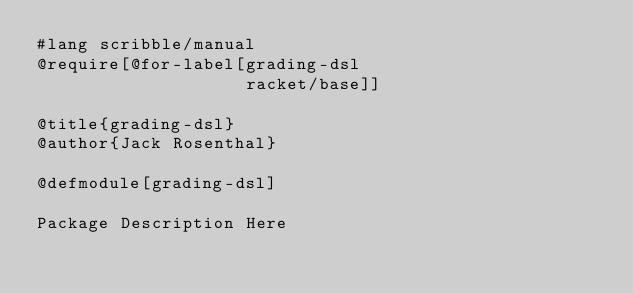<code> <loc_0><loc_0><loc_500><loc_500><_Racket_>#lang scribble/manual
@require[@for-label[grading-dsl
                    racket/base]]

@title{grading-dsl}
@author{Jack Rosenthal}

@defmodule[grading-dsl]

Package Description Here
</code> 